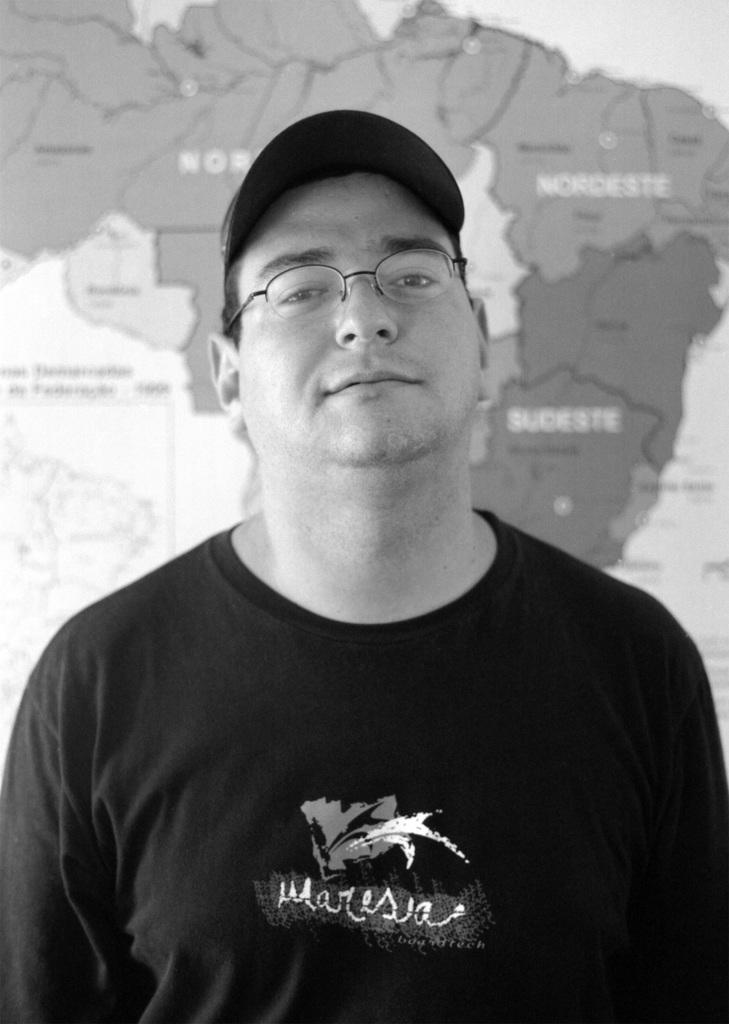What is the main subject of the image? There is a man standing in the center of the image. What accessories is the man wearing? The man is wearing spectacles and a hat. What can be seen in the background of the image? There is a map in the background of the image. What type of lead can be seen in the man's hand in the image? There is no lead visible in the man's hand in the image. Can you tell me how many times the man bites his hat in the image? The man does not bite his hat in the image; he is simply wearing it. 